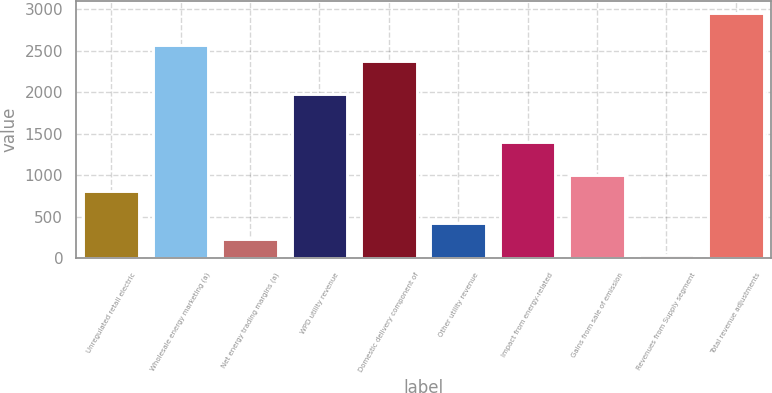<chart> <loc_0><loc_0><loc_500><loc_500><bar_chart><fcel>Unregulated retail electric<fcel>Wholesale energy marketing (a)<fcel>Net energy trading margins (a)<fcel>WPD utility revenue<fcel>Domestic delivery component of<fcel>Other utility revenue<fcel>Impact from energy-related<fcel>Gains from sale of emission<fcel>Revenues from Supply segment<fcel>Total revenue adjustments<nl><fcel>814<fcel>2564.5<fcel>230.5<fcel>1981<fcel>2370<fcel>425<fcel>1397.5<fcel>1008.5<fcel>36<fcel>2953.5<nl></chart> 